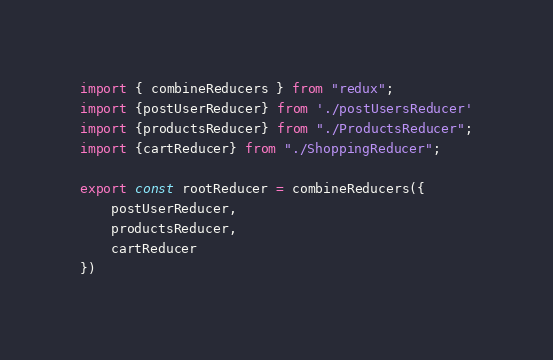Convert code to text. <code><loc_0><loc_0><loc_500><loc_500><_JavaScript_>import { combineReducers } from "redux";
import {postUserReducer} from './postUsersReducer'
import {productsReducer} from "./ProductsReducer";
import {cartReducer} from "./ShoppingReducer";

export const rootReducer = combineReducers({
    postUserReducer,
    productsReducer,
    cartReducer
})</code> 